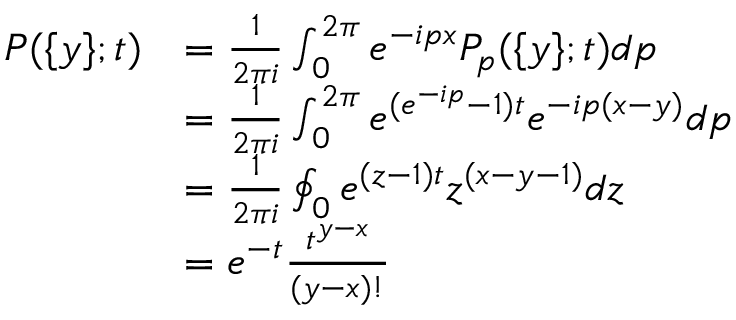<formula> <loc_0><loc_0><loc_500><loc_500>\begin{array} { r l } { P ( \{ y \} ; t ) } & { = \frac { 1 } { 2 \pi i } \int _ { 0 } ^ { 2 \pi } e ^ { - i p x } P _ { p } ( \{ y \} ; t ) d p } \\ & { = \frac { 1 } { 2 \pi i } \int _ { 0 } ^ { 2 \pi } e ^ { ( e ^ { - i p } - 1 ) t } e ^ { - i p ( x - y ) } d p } \\ & { = \frac { 1 } { 2 \pi i } \oint _ { 0 } e ^ { ( z - 1 ) t } z ^ { ( x - y - 1 ) } d z } \\ & { = e ^ { - t } \frac { t ^ { y - x } } { ( y - x ) ! } } \end{array}</formula> 